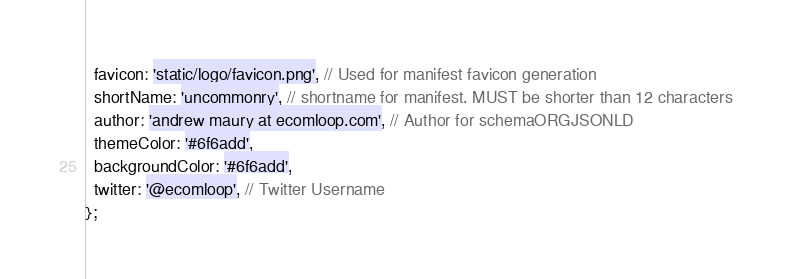Convert code to text. <code><loc_0><loc_0><loc_500><loc_500><_JavaScript_>  favicon: 'static/logo/favicon.png', // Used for manifest favicon generation
  shortName: 'uncommonry', // shortname for manifest. MUST be shorter than 12 characters
  author: 'andrew maury at ecomloop.com', // Author for schemaORGJSONLD
  themeColor: '#6f6add',
  backgroundColor: '#6f6add',
  twitter: '@ecomloop', // Twitter Username
};
</code> 